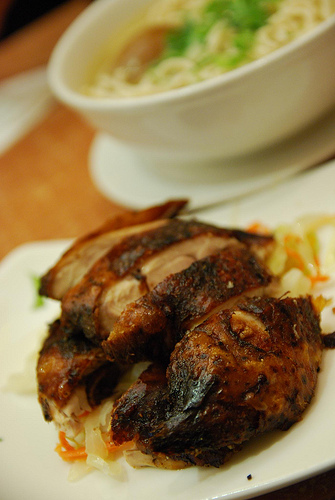<image>
Is the chicken next to the plate? No. The chicken is not positioned next to the plate. They are located in different areas of the scene. 